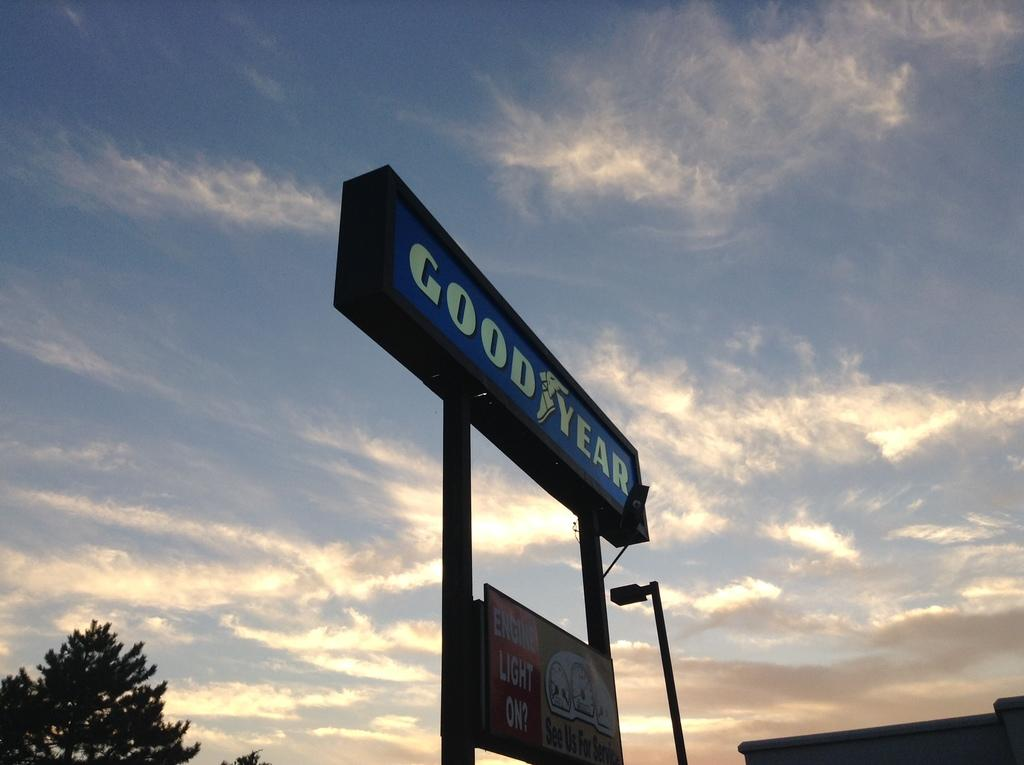<image>
Write a terse but informative summary of the picture. A goodyear tire sign against a blue sky with clouds. 